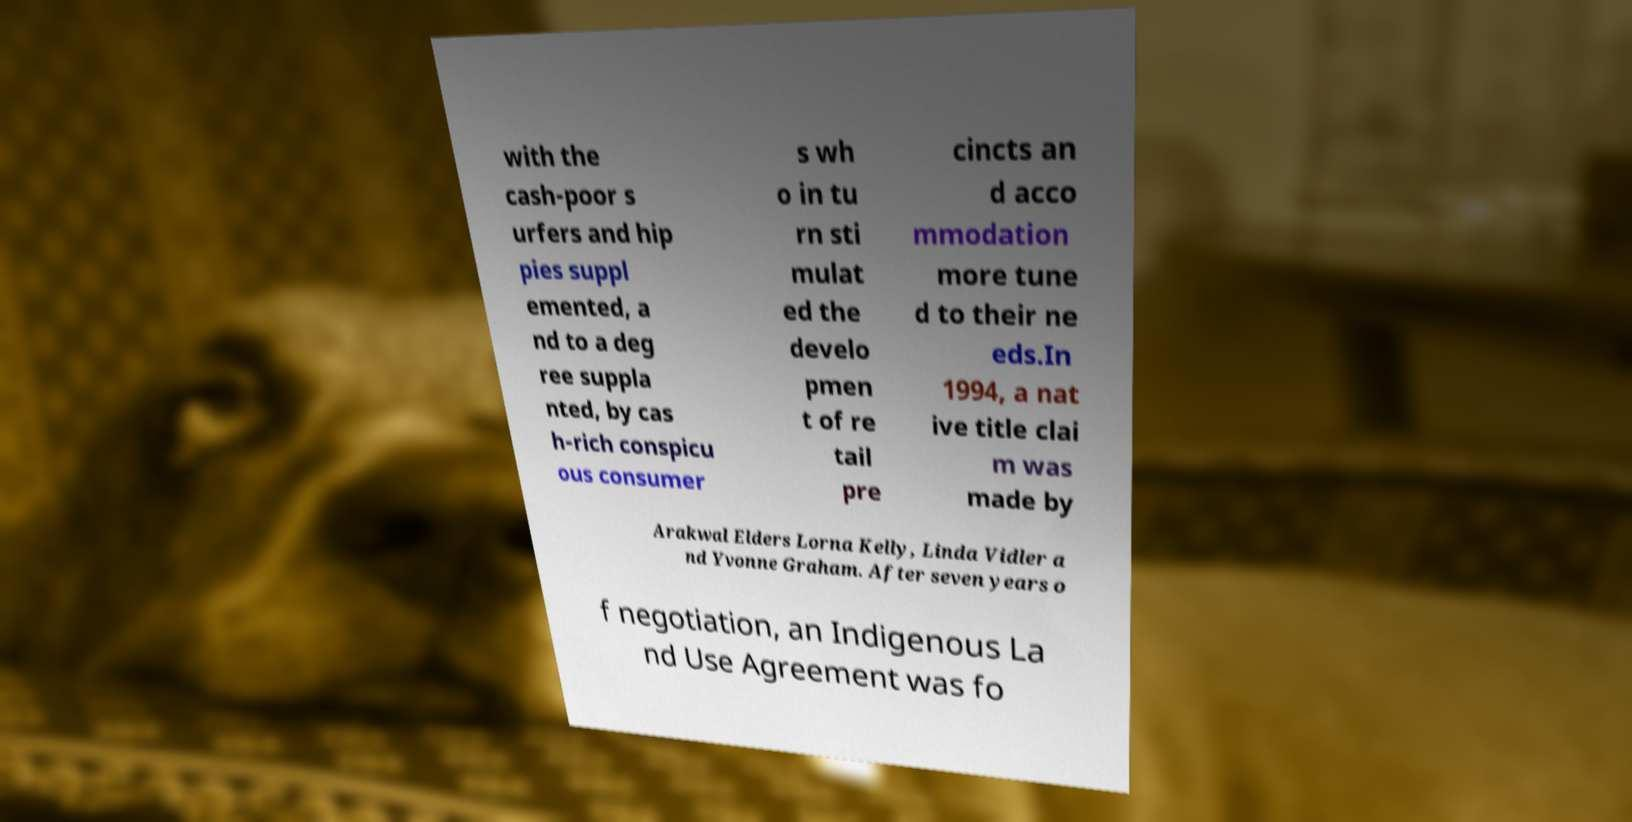Please read and relay the text visible in this image. What does it say? with the cash-poor s urfers and hip pies suppl emented, a nd to a deg ree suppla nted, by cas h-rich conspicu ous consumer s wh o in tu rn sti mulat ed the develo pmen t of re tail pre cincts an d acco mmodation more tune d to their ne eds.In 1994, a nat ive title clai m was made by Arakwal Elders Lorna Kelly, Linda Vidler a nd Yvonne Graham. After seven years o f negotiation, an Indigenous La nd Use Agreement was fo 